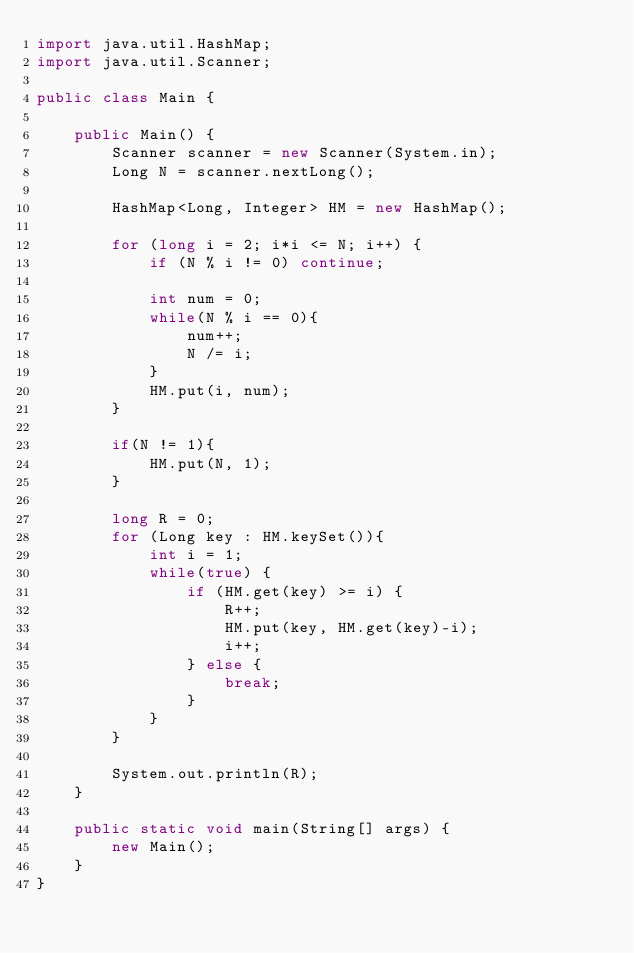<code> <loc_0><loc_0><loc_500><loc_500><_Java_>import java.util.HashMap;
import java.util.Scanner;

public class Main {

    public Main() {
        Scanner scanner = new Scanner(System.in);
        Long N = scanner.nextLong();

        HashMap<Long, Integer> HM = new HashMap();

        for (long i = 2; i*i <= N; i++) {
            if (N % i != 0) continue;

            int num = 0;
            while(N % i == 0){
                num++;
                N /= i;
            }
            HM.put(i, num);
        }

        if(N != 1){
            HM.put(N, 1);
        }

        long R = 0;
        for (Long key : HM.keySet()){
            int i = 1;
            while(true) {
                if (HM.get(key) >= i) {
                    R++;
                    HM.put(key, HM.get(key)-i);
                    i++;
                } else {
                    break;
                }
            }
        }

        System.out.println(R);
    }

    public static void main(String[] args) {
        new Main();
    }
}
</code> 